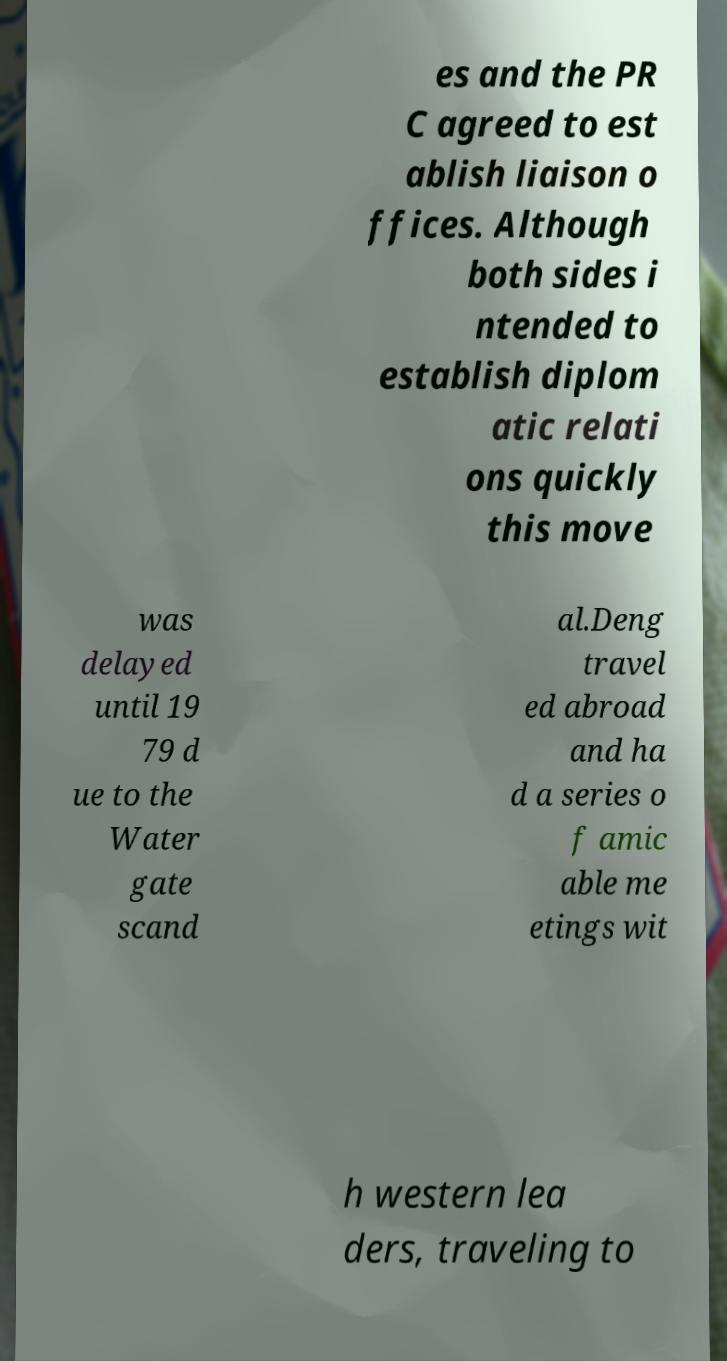For documentation purposes, I need the text within this image transcribed. Could you provide that? es and the PR C agreed to est ablish liaison o ffices. Although both sides i ntended to establish diplom atic relati ons quickly this move was delayed until 19 79 d ue to the Water gate scand al.Deng travel ed abroad and ha d a series o f amic able me etings wit h western lea ders, traveling to 